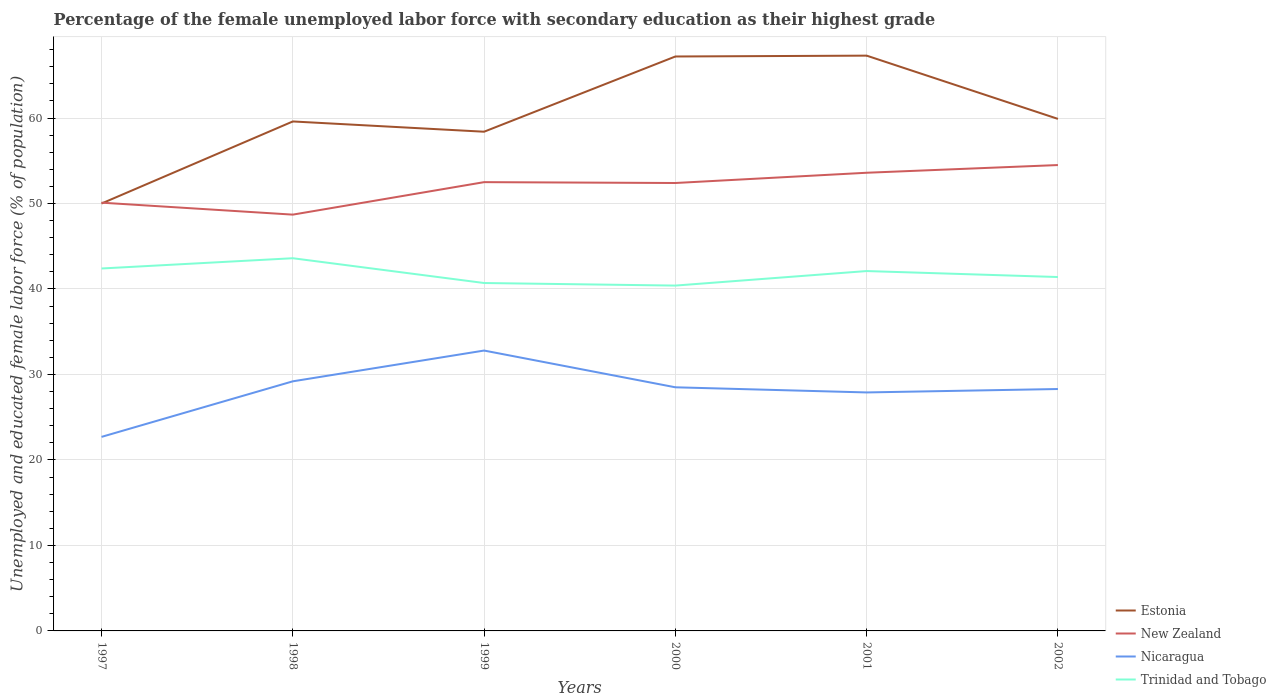Does the line corresponding to Nicaragua intersect with the line corresponding to Trinidad and Tobago?
Your answer should be compact. No. Across all years, what is the maximum percentage of the unemployed female labor force with secondary education in Estonia?
Offer a very short reply. 50. In which year was the percentage of the unemployed female labor force with secondary education in Estonia maximum?
Offer a terse response. 1997. What is the total percentage of the unemployed female labor force with secondary education in Estonia in the graph?
Give a very brief answer. -8.8. What is the difference between the highest and the second highest percentage of the unemployed female labor force with secondary education in Trinidad and Tobago?
Provide a succinct answer. 3.2. How many years are there in the graph?
Offer a terse response. 6. Where does the legend appear in the graph?
Provide a short and direct response. Bottom right. What is the title of the graph?
Keep it short and to the point. Percentage of the female unemployed labor force with secondary education as their highest grade. What is the label or title of the X-axis?
Give a very brief answer. Years. What is the label or title of the Y-axis?
Offer a terse response. Unemployed and educated female labor force (% of population). What is the Unemployed and educated female labor force (% of population) in Estonia in 1997?
Make the answer very short. 50. What is the Unemployed and educated female labor force (% of population) in New Zealand in 1997?
Your answer should be very brief. 50.1. What is the Unemployed and educated female labor force (% of population) of Nicaragua in 1997?
Provide a succinct answer. 22.7. What is the Unemployed and educated female labor force (% of population) of Trinidad and Tobago in 1997?
Provide a succinct answer. 42.4. What is the Unemployed and educated female labor force (% of population) of Estonia in 1998?
Provide a short and direct response. 59.6. What is the Unemployed and educated female labor force (% of population) of New Zealand in 1998?
Offer a terse response. 48.7. What is the Unemployed and educated female labor force (% of population) of Nicaragua in 1998?
Offer a terse response. 29.2. What is the Unemployed and educated female labor force (% of population) in Trinidad and Tobago in 1998?
Your answer should be compact. 43.6. What is the Unemployed and educated female labor force (% of population) in Estonia in 1999?
Your response must be concise. 58.4. What is the Unemployed and educated female labor force (% of population) of New Zealand in 1999?
Provide a succinct answer. 52.5. What is the Unemployed and educated female labor force (% of population) in Nicaragua in 1999?
Keep it short and to the point. 32.8. What is the Unemployed and educated female labor force (% of population) in Trinidad and Tobago in 1999?
Offer a terse response. 40.7. What is the Unemployed and educated female labor force (% of population) in Estonia in 2000?
Make the answer very short. 67.2. What is the Unemployed and educated female labor force (% of population) in New Zealand in 2000?
Provide a succinct answer. 52.4. What is the Unemployed and educated female labor force (% of population) in Nicaragua in 2000?
Provide a short and direct response. 28.5. What is the Unemployed and educated female labor force (% of population) of Trinidad and Tobago in 2000?
Ensure brevity in your answer.  40.4. What is the Unemployed and educated female labor force (% of population) in Estonia in 2001?
Your response must be concise. 67.3. What is the Unemployed and educated female labor force (% of population) of New Zealand in 2001?
Keep it short and to the point. 53.6. What is the Unemployed and educated female labor force (% of population) in Nicaragua in 2001?
Offer a very short reply. 27.9. What is the Unemployed and educated female labor force (% of population) in Trinidad and Tobago in 2001?
Keep it short and to the point. 42.1. What is the Unemployed and educated female labor force (% of population) in Estonia in 2002?
Give a very brief answer. 59.9. What is the Unemployed and educated female labor force (% of population) in New Zealand in 2002?
Make the answer very short. 54.5. What is the Unemployed and educated female labor force (% of population) of Nicaragua in 2002?
Offer a very short reply. 28.3. What is the Unemployed and educated female labor force (% of population) of Trinidad and Tobago in 2002?
Your answer should be very brief. 41.4. Across all years, what is the maximum Unemployed and educated female labor force (% of population) of Estonia?
Your answer should be compact. 67.3. Across all years, what is the maximum Unemployed and educated female labor force (% of population) in New Zealand?
Give a very brief answer. 54.5. Across all years, what is the maximum Unemployed and educated female labor force (% of population) in Nicaragua?
Offer a terse response. 32.8. Across all years, what is the maximum Unemployed and educated female labor force (% of population) of Trinidad and Tobago?
Your answer should be compact. 43.6. Across all years, what is the minimum Unemployed and educated female labor force (% of population) of Estonia?
Your response must be concise. 50. Across all years, what is the minimum Unemployed and educated female labor force (% of population) in New Zealand?
Your response must be concise. 48.7. Across all years, what is the minimum Unemployed and educated female labor force (% of population) in Nicaragua?
Provide a succinct answer. 22.7. Across all years, what is the minimum Unemployed and educated female labor force (% of population) of Trinidad and Tobago?
Keep it short and to the point. 40.4. What is the total Unemployed and educated female labor force (% of population) of Estonia in the graph?
Give a very brief answer. 362.4. What is the total Unemployed and educated female labor force (% of population) of New Zealand in the graph?
Provide a short and direct response. 311.8. What is the total Unemployed and educated female labor force (% of population) in Nicaragua in the graph?
Provide a succinct answer. 169.4. What is the total Unemployed and educated female labor force (% of population) of Trinidad and Tobago in the graph?
Keep it short and to the point. 250.6. What is the difference between the Unemployed and educated female labor force (% of population) of Estonia in 1997 and that in 1998?
Offer a terse response. -9.6. What is the difference between the Unemployed and educated female labor force (% of population) in New Zealand in 1997 and that in 1998?
Give a very brief answer. 1.4. What is the difference between the Unemployed and educated female labor force (% of population) in Trinidad and Tobago in 1997 and that in 1998?
Provide a short and direct response. -1.2. What is the difference between the Unemployed and educated female labor force (% of population) in Estonia in 1997 and that in 1999?
Ensure brevity in your answer.  -8.4. What is the difference between the Unemployed and educated female labor force (% of population) of Estonia in 1997 and that in 2000?
Provide a short and direct response. -17.2. What is the difference between the Unemployed and educated female labor force (% of population) in Estonia in 1997 and that in 2001?
Your answer should be compact. -17.3. What is the difference between the Unemployed and educated female labor force (% of population) of New Zealand in 1997 and that in 2001?
Your response must be concise. -3.5. What is the difference between the Unemployed and educated female labor force (% of population) of Trinidad and Tobago in 1997 and that in 2001?
Offer a terse response. 0.3. What is the difference between the Unemployed and educated female labor force (% of population) in New Zealand in 1997 and that in 2002?
Your response must be concise. -4.4. What is the difference between the Unemployed and educated female labor force (% of population) of Nicaragua in 1997 and that in 2002?
Offer a very short reply. -5.6. What is the difference between the Unemployed and educated female labor force (% of population) in Trinidad and Tobago in 1998 and that in 1999?
Your answer should be very brief. 2.9. What is the difference between the Unemployed and educated female labor force (% of population) in Estonia in 1998 and that in 2000?
Keep it short and to the point. -7.6. What is the difference between the Unemployed and educated female labor force (% of population) in New Zealand in 1998 and that in 2000?
Your response must be concise. -3.7. What is the difference between the Unemployed and educated female labor force (% of population) in Nicaragua in 1998 and that in 2000?
Keep it short and to the point. 0.7. What is the difference between the Unemployed and educated female labor force (% of population) of Estonia in 1998 and that in 2001?
Your response must be concise. -7.7. What is the difference between the Unemployed and educated female labor force (% of population) of Trinidad and Tobago in 1998 and that in 2001?
Your answer should be compact. 1.5. What is the difference between the Unemployed and educated female labor force (% of population) in Estonia in 1998 and that in 2002?
Keep it short and to the point. -0.3. What is the difference between the Unemployed and educated female labor force (% of population) in Nicaragua in 1998 and that in 2002?
Provide a short and direct response. 0.9. What is the difference between the Unemployed and educated female labor force (% of population) of New Zealand in 1999 and that in 2000?
Provide a short and direct response. 0.1. What is the difference between the Unemployed and educated female labor force (% of population) of Nicaragua in 1999 and that in 2000?
Your response must be concise. 4.3. What is the difference between the Unemployed and educated female labor force (% of population) of Trinidad and Tobago in 1999 and that in 2000?
Keep it short and to the point. 0.3. What is the difference between the Unemployed and educated female labor force (% of population) of New Zealand in 1999 and that in 2001?
Offer a very short reply. -1.1. What is the difference between the Unemployed and educated female labor force (% of population) in Nicaragua in 1999 and that in 2001?
Your response must be concise. 4.9. What is the difference between the Unemployed and educated female labor force (% of population) in Estonia in 1999 and that in 2002?
Your answer should be compact. -1.5. What is the difference between the Unemployed and educated female labor force (% of population) in Trinidad and Tobago in 2000 and that in 2001?
Keep it short and to the point. -1.7. What is the difference between the Unemployed and educated female labor force (% of population) in Estonia in 2000 and that in 2002?
Make the answer very short. 7.3. What is the difference between the Unemployed and educated female labor force (% of population) in New Zealand in 2000 and that in 2002?
Make the answer very short. -2.1. What is the difference between the Unemployed and educated female labor force (% of population) in Nicaragua in 2000 and that in 2002?
Your response must be concise. 0.2. What is the difference between the Unemployed and educated female labor force (% of population) of Estonia in 2001 and that in 2002?
Offer a very short reply. 7.4. What is the difference between the Unemployed and educated female labor force (% of population) of Estonia in 1997 and the Unemployed and educated female labor force (% of population) of New Zealand in 1998?
Your answer should be very brief. 1.3. What is the difference between the Unemployed and educated female labor force (% of population) of Estonia in 1997 and the Unemployed and educated female labor force (% of population) of Nicaragua in 1998?
Provide a succinct answer. 20.8. What is the difference between the Unemployed and educated female labor force (% of population) of New Zealand in 1997 and the Unemployed and educated female labor force (% of population) of Nicaragua in 1998?
Keep it short and to the point. 20.9. What is the difference between the Unemployed and educated female labor force (% of population) in Nicaragua in 1997 and the Unemployed and educated female labor force (% of population) in Trinidad and Tobago in 1998?
Keep it short and to the point. -20.9. What is the difference between the Unemployed and educated female labor force (% of population) in Estonia in 1997 and the Unemployed and educated female labor force (% of population) in New Zealand in 1999?
Your answer should be compact. -2.5. What is the difference between the Unemployed and educated female labor force (% of population) of New Zealand in 1997 and the Unemployed and educated female labor force (% of population) of Nicaragua in 1999?
Provide a short and direct response. 17.3. What is the difference between the Unemployed and educated female labor force (% of population) in Nicaragua in 1997 and the Unemployed and educated female labor force (% of population) in Trinidad and Tobago in 1999?
Your answer should be compact. -18. What is the difference between the Unemployed and educated female labor force (% of population) in Estonia in 1997 and the Unemployed and educated female labor force (% of population) in Trinidad and Tobago in 2000?
Your response must be concise. 9.6. What is the difference between the Unemployed and educated female labor force (% of population) in New Zealand in 1997 and the Unemployed and educated female labor force (% of population) in Nicaragua in 2000?
Keep it short and to the point. 21.6. What is the difference between the Unemployed and educated female labor force (% of population) in Nicaragua in 1997 and the Unemployed and educated female labor force (% of population) in Trinidad and Tobago in 2000?
Give a very brief answer. -17.7. What is the difference between the Unemployed and educated female labor force (% of population) of Estonia in 1997 and the Unemployed and educated female labor force (% of population) of Nicaragua in 2001?
Offer a terse response. 22.1. What is the difference between the Unemployed and educated female labor force (% of population) in Estonia in 1997 and the Unemployed and educated female labor force (% of population) in Trinidad and Tobago in 2001?
Offer a terse response. 7.9. What is the difference between the Unemployed and educated female labor force (% of population) of Nicaragua in 1997 and the Unemployed and educated female labor force (% of population) of Trinidad and Tobago in 2001?
Ensure brevity in your answer.  -19.4. What is the difference between the Unemployed and educated female labor force (% of population) in Estonia in 1997 and the Unemployed and educated female labor force (% of population) in New Zealand in 2002?
Provide a short and direct response. -4.5. What is the difference between the Unemployed and educated female labor force (% of population) of Estonia in 1997 and the Unemployed and educated female labor force (% of population) of Nicaragua in 2002?
Ensure brevity in your answer.  21.7. What is the difference between the Unemployed and educated female labor force (% of population) in New Zealand in 1997 and the Unemployed and educated female labor force (% of population) in Nicaragua in 2002?
Make the answer very short. 21.8. What is the difference between the Unemployed and educated female labor force (% of population) in Nicaragua in 1997 and the Unemployed and educated female labor force (% of population) in Trinidad and Tobago in 2002?
Provide a succinct answer. -18.7. What is the difference between the Unemployed and educated female labor force (% of population) of Estonia in 1998 and the Unemployed and educated female labor force (% of population) of New Zealand in 1999?
Your answer should be compact. 7.1. What is the difference between the Unemployed and educated female labor force (% of population) of Estonia in 1998 and the Unemployed and educated female labor force (% of population) of Nicaragua in 1999?
Your answer should be compact. 26.8. What is the difference between the Unemployed and educated female labor force (% of population) of Estonia in 1998 and the Unemployed and educated female labor force (% of population) of Trinidad and Tobago in 1999?
Your answer should be compact. 18.9. What is the difference between the Unemployed and educated female labor force (% of population) of New Zealand in 1998 and the Unemployed and educated female labor force (% of population) of Nicaragua in 1999?
Your answer should be compact. 15.9. What is the difference between the Unemployed and educated female labor force (% of population) of Estonia in 1998 and the Unemployed and educated female labor force (% of population) of New Zealand in 2000?
Make the answer very short. 7.2. What is the difference between the Unemployed and educated female labor force (% of population) of Estonia in 1998 and the Unemployed and educated female labor force (% of population) of Nicaragua in 2000?
Your answer should be very brief. 31.1. What is the difference between the Unemployed and educated female labor force (% of population) in New Zealand in 1998 and the Unemployed and educated female labor force (% of population) in Nicaragua in 2000?
Make the answer very short. 20.2. What is the difference between the Unemployed and educated female labor force (% of population) of New Zealand in 1998 and the Unemployed and educated female labor force (% of population) of Trinidad and Tobago in 2000?
Keep it short and to the point. 8.3. What is the difference between the Unemployed and educated female labor force (% of population) of Nicaragua in 1998 and the Unemployed and educated female labor force (% of population) of Trinidad and Tobago in 2000?
Offer a very short reply. -11.2. What is the difference between the Unemployed and educated female labor force (% of population) in Estonia in 1998 and the Unemployed and educated female labor force (% of population) in New Zealand in 2001?
Give a very brief answer. 6. What is the difference between the Unemployed and educated female labor force (% of population) of Estonia in 1998 and the Unemployed and educated female labor force (% of population) of Nicaragua in 2001?
Your answer should be very brief. 31.7. What is the difference between the Unemployed and educated female labor force (% of population) in New Zealand in 1998 and the Unemployed and educated female labor force (% of population) in Nicaragua in 2001?
Provide a succinct answer. 20.8. What is the difference between the Unemployed and educated female labor force (% of population) in New Zealand in 1998 and the Unemployed and educated female labor force (% of population) in Trinidad and Tobago in 2001?
Provide a succinct answer. 6.6. What is the difference between the Unemployed and educated female labor force (% of population) of Nicaragua in 1998 and the Unemployed and educated female labor force (% of population) of Trinidad and Tobago in 2001?
Your answer should be compact. -12.9. What is the difference between the Unemployed and educated female labor force (% of population) of Estonia in 1998 and the Unemployed and educated female labor force (% of population) of New Zealand in 2002?
Offer a very short reply. 5.1. What is the difference between the Unemployed and educated female labor force (% of population) of Estonia in 1998 and the Unemployed and educated female labor force (% of population) of Nicaragua in 2002?
Provide a short and direct response. 31.3. What is the difference between the Unemployed and educated female labor force (% of population) of New Zealand in 1998 and the Unemployed and educated female labor force (% of population) of Nicaragua in 2002?
Offer a very short reply. 20.4. What is the difference between the Unemployed and educated female labor force (% of population) in New Zealand in 1998 and the Unemployed and educated female labor force (% of population) in Trinidad and Tobago in 2002?
Provide a short and direct response. 7.3. What is the difference between the Unemployed and educated female labor force (% of population) of Estonia in 1999 and the Unemployed and educated female labor force (% of population) of Nicaragua in 2000?
Your response must be concise. 29.9. What is the difference between the Unemployed and educated female labor force (% of population) in Estonia in 1999 and the Unemployed and educated female labor force (% of population) in Trinidad and Tobago in 2000?
Ensure brevity in your answer.  18. What is the difference between the Unemployed and educated female labor force (% of population) in Estonia in 1999 and the Unemployed and educated female labor force (% of population) in Nicaragua in 2001?
Offer a terse response. 30.5. What is the difference between the Unemployed and educated female labor force (% of population) in Estonia in 1999 and the Unemployed and educated female labor force (% of population) in Trinidad and Tobago in 2001?
Your answer should be very brief. 16.3. What is the difference between the Unemployed and educated female labor force (% of population) in New Zealand in 1999 and the Unemployed and educated female labor force (% of population) in Nicaragua in 2001?
Your answer should be very brief. 24.6. What is the difference between the Unemployed and educated female labor force (% of population) in Nicaragua in 1999 and the Unemployed and educated female labor force (% of population) in Trinidad and Tobago in 2001?
Ensure brevity in your answer.  -9.3. What is the difference between the Unemployed and educated female labor force (% of population) in Estonia in 1999 and the Unemployed and educated female labor force (% of population) in New Zealand in 2002?
Offer a very short reply. 3.9. What is the difference between the Unemployed and educated female labor force (% of population) of Estonia in 1999 and the Unemployed and educated female labor force (% of population) of Nicaragua in 2002?
Provide a succinct answer. 30.1. What is the difference between the Unemployed and educated female labor force (% of population) of New Zealand in 1999 and the Unemployed and educated female labor force (% of population) of Nicaragua in 2002?
Provide a short and direct response. 24.2. What is the difference between the Unemployed and educated female labor force (% of population) in New Zealand in 1999 and the Unemployed and educated female labor force (% of population) in Trinidad and Tobago in 2002?
Provide a succinct answer. 11.1. What is the difference between the Unemployed and educated female labor force (% of population) of Nicaragua in 1999 and the Unemployed and educated female labor force (% of population) of Trinidad and Tobago in 2002?
Make the answer very short. -8.6. What is the difference between the Unemployed and educated female labor force (% of population) in Estonia in 2000 and the Unemployed and educated female labor force (% of population) in New Zealand in 2001?
Keep it short and to the point. 13.6. What is the difference between the Unemployed and educated female labor force (% of population) in Estonia in 2000 and the Unemployed and educated female labor force (% of population) in Nicaragua in 2001?
Ensure brevity in your answer.  39.3. What is the difference between the Unemployed and educated female labor force (% of population) of Estonia in 2000 and the Unemployed and educated female labor force (% of population) of Trinidad and Tobago in 2001?
Provide a succinct answer. 25.1. What is the difference between the Unemployed and educated female labor force (% of population) of New Zealand in 2000 and the Unemployed and educated female labor force (% of population) of Trinidad and Tobago in 2001?
Your response must be concise. 10.3. What is the difference between the Unemployed and educated female labor force (% of population) in Nicaragua in 2000 and the Unemployed and educated female labor force (% of population) in Trinidad and Tobago in 2001?
Give a very brief answer. -13.6. What is the difference between the Unemployed and educated female labor force (% of population) in Estonia in 2000 and the Unemployed and educated female labor force (% of population) in New Zealand in 2002?
Your answer should be very brief. 12.7. What is the difference between the Unemployed and educated female labor force (% of population) of Estonia in 2000 and the Unemployed and educated female labor force (% of population) of Nicaragua in 2002?
Your answer should be very brief. 38.9. What is the difference between the Unemployed and educated female labor force (% of population) in Estonia in 2000 and the Unemployed and educated female labor force (% of population) in Trinidad and Tobago in 2002?
Offer a very short reply. 25.8. What is the difference between the Unemployed and educated female labor force (% of population) in New Zealand in 2000 and the Unemployed and educated female labor force (% of population) in Nicaragua in 2002?
Your response must be concise. 24.1. What is the difference between the Unemployed and educated female labor force (% of population) in Nicaragua in 2000 and the Unemployed and educated female labor force (% of population) in Trinidad and Tobago in 2002?
Make the answer very short. -12.9. What is the difference between the Unemployed and educated female labor force (% of population) in Estonia in 2001 and the Unemployed and educated female labor force (% of population) in New Zealand in 2002?
Offer a terse response. 12.8. What is the difference between the Unemployed and educated female labor force (% of population) in Estonia in 2001 and the Unemployed and educated female labor force (% of population) in Nicaragua in 2002?
Offer a very short reply. 39. What is the difference between the Unemployed and educated female labor force (% of population) of Estonia in 2001 and the Unemployed and educated female labor force (% of population) of Trinidad and Tobago in 2002?
Offer a very short reply. 25.9. What is the difference between the Unemployed and educated female labor force (% of population) of New Zealand in 2001 and the Unemployed and educated female labor force (% of population) of Nicaragua in 2002?
Your response must be concise. 25.3. What is the average Unemployed and educated female labor force (% of population) in Estonia per year?
Keep it short and to the point. 60.4. What is the average Unemployed and educated female labor force (% of population) in New Zealand per year?
Give a very brief answer. 51.97. What is the average Unemployed and educated female labor force (% of population) in Nicaragua per year?
Provide a short and direct response. 28.23. What is the average Unemployed and educated female labor force (% of population) of Trinidad and Tobago per year?
Your answer should be very brief. 41.77. In the year 1997, what is the difference between the Unemployed and educated female labor force (% of population) of Estonia and Unemployed and educated female labor force (% of population) of New Zealand?
Provide a short and direct response. -0.1. In the year 1997, what is the difference between the Unemployed and educated female labor force (% of population) in Estonia and Unemployed and educated female labor force (% of population) in Nicaragua?
Provide a succinct answer. 27.3. In the year 1997, what is the difference between the Unemployed and educated female labor force (% of population) in New Zealand and Unemployed and educated female labor force (% of population) in Nicaragua?
Your answer should be compact. 27.4. In the year 1997, what is the difference between the Unemployed and educated female labor force (% of population) of New Zealand and Unemployed and educated female labor force (% of population) of Trinidad and Tobago?
Give a very brief answer. 7.7. In the year 1997, what is the difference between the Unemployed and educated female labor force (% of population) of Nicaragua and Unemployed and educated female labor force (% of population) of Trinidad and Tobago?
Provide a short and direct response. -19.7. In the year 1998, what is the difference between the Unemployed and educated female labor force (% of population) in Estonia and Unemployed and educated female labor force (% of population) in Nicaragua?
Make the answer very short. 30.4. In the year 1998, what is the difference between the Unemployed and educated female labor force (% of population) in New Zealand and Unemployed and educated female labor force (% of population) in Nicaragua?
Give a very brief answer. 19.5. In the year 1998, what is the difference between the Unemployed and educated female labor force (% of population) in Nicaragua and Unemployed and educated female labor force (% of population) in Trinidad and Tobago?
Offer a terse response. -14.4. In the year 1999, what is the difference between the Unemployed and educated female labor force (% of population) of Estonia and Unemployed and educated female labor force (% of population) of Nicaragua?
Your answer should be very brief. 25.6. In the year 1999, what is the difference between the Unemployed and educated female labor force (% of population) in Estonia and Unemployed and educated female labor force (% of population) in Trinidad and Tobago?
Ensure brevity in your answer.  17.7. In the year 1999, what is the difference between the Unemployed and educated female labor force (% of population) of New Zealand and Unemployed and educated female labor force (% of population) of Nicaragua?
Offer a very short reply. 19.7. In the year 1999, what is the difference between the Unemployed and educated female labor force (% of population) in New Zealand and Unemployed and educated female labor force (% of population) in Trinidad and Tobago?
Provide a succinct answer. 11.8. In the year 1999, what is the difference between the Unemployed and educated female labor force (% of population) in Nicaragua and Unemployed and educated female labor force (% of population) in Trinidad and Tobago?
Your answer should be compact. -7.9. In the year 2000, what is the difference between the Unemployed and educated female labor force (% of population) in Estonia and Unemployed and educated female labor force (% of population) in New Zealand?
Provide a succinct answer. 14.8. In the year 2000, what is the difference between the Unemployed and educated female labor force (% of population) of Estonia and Unemployed and educated female labor force (% of population) of Nicaragua?
Provide a short and direct response. 38.7. In the year 2000, what is the difference between the Unemployed and educated female labor force (% of population) of Estonia and Unemployed and educated female labor force (% of population) of Trinidad and Tobago?
Your answer should be very brief. 26.8. In the year 2000, what is the difference between the Unemployed and educated female labor force (% of population) in New Zealand and Unemployed and educated female labor force (% of population) in Nicaragua?
Your answer should be very brief. 23.9. In the year 2000, what is the difference between the Unemployed and educated female labor force (% of population) in New Zealand and Unemployed and educated female labor force (% of population) in Trinidad and Tobago?
Offer a terse response. 12. In the year 2000, what is the difference between the Unemployed and educated female labor force (% of population) in Nicaragua and Unemployed and educated female labor force (% of population) in Trinidad and Tobago?
Make the answer very short. -11.9. In the year 2001, what is the difference between the Unemployed and educated female labor force (% of population) in Estonia and Unemployed and educated female labor force (% of population) in Nicaragua?
Ensure brevity in your answer.  39.4. In the year 2001, what is the difference between the Unemployed and educated female labor force (% of population) of Estonia and Unemployed and educated female labor force (% of population) of Trinidad and Tobago?
Your answer should be compact. 25.2. In the year 2001, what is the difference between the Unemployed and educated female labor force (% of population) in New Zealand and Unemployed and educated female labor force (% of population) in Nicaragua?
Ensure brevity in your answer.  25.7. In the year 2001, what is the difference between the Unemployed and educated female labor force (% of population) in New Zealand and Unemployed and educated female labor force (% of population) in Trinidad and Tobago?
Offer a very short reply. 11.5. In the year 2002, what is the difference between the Unemployed and educated female labor force (% of population) of Estonia and Unemployed and educated female labor force (% of population) of Nicaragua?
Keep it short and to the point. 31.6. In the year 2002, what is the difference between the Unemployed and educated female labor force (% of population) of New Zealand and Unemployed and educated female labor force (% of population) of Nicaragua?
Offer a terse response. 26.2. What is the ratio of the Unemployed and educated female labor force (% of population) of Estonia in 1997 to that in 1998?
Provide a short and direct response. 0.84. What is the ratio of the Unemployed and educated female labor force (% of population) in New Zealand in 1997 to that in 1998?
Provide a succinct answer. 1.03. What is the ratio of the Unemployed and educated female labor force (% of population) of Nicaragua in 1997 to that in 1998?
Provide a succinct answer. 0.78. What is the ratio of the Unemployed and educated female labor force (% of population) of Trinidad and Tobago in 1997 to that in 1998?
Provide a short and direct response. 0.97. What is the ratio of the Unemployed and educated female labor force (% of population) in Estonia in 1997 to that in 1999?
Keep it short and to the point. 0.86. What is the ratio of the Unemployed and educated female labor force (% of population) of New Zealand in 1997 to that in 1999?
Keep it short and to the point. 0.95. What is the ratio of the Unemployed and educated female labor force (% of population) in Nicaragua in 1997 to that in 1999?
Ensure brevity in your answer.  0.69. What is the ratio of the Unemployed and educated female labor force (% of population) in Trinidad and Tobago in 1997 to that in 1999?
Your answer should be compact. 1.04. What is the ratio of the Unemployed and educated female labor force (% of population) of Estonia in 1997 to that in 2000?
Your answer should be compact. 0.74. What is the ratio of the Unemployed and educated female labor force (% of population) of New Zealand in 1997 to that in 2000?
Ensure brevity in your answer.  0.96. What is the ratio of the Unemployed and educated female labor force (% of population) of Nicaragua in 1997 to that in 2000?
Your answer should be very brief. 0.8. What is the ratio of the Unemployed and educated female labor force (% of population) in Trinidad and Tobago in 1997 to that in 2000?
Ensure brevity in your answer.  1.05. What is the ratio of the Unemployed and educated female labor force (% of population) in Estonia in 1997 to that in 2001?
Offer a terse response. 0.74. What is the ratio of the Unemployed and educated female labor force (% of population) of New Zealand in 1997 to that in 2001?
Provide a short and direct response. 0.93. What is the ratio of the Unemployed and educated female labor force (% of population) in Nicaragua in 1997 to that in 2001?
Offer a very short reply. 0.81. What is the ratio of the Unemployed and educated female labor force (% of population) in Trinidad and Tobago in 1997 to that in 2001?
Keep it short and to the point. 1.01. What is the ratio of the Unemployed and educated female labor force (% of population) of Estonia in 1997 to that in 2002?
Ensure brevity in your answer.  0.83. What is the ratio of the Unemployed and educated female labor force (% of population) in New Zealand in 1997 to that in 2002?
Your response must be concise. 0.92. What is the ratio of the Unemployed and educated female labor force (% of population) in Nicaragua in 1997 to that in 2002?
Make the answer very short. 0.8. What is the ratio of the Unemployed and educated female labor force (% of population) of Trinidad and Tobago in 1997 to that in 2002?
Your response must be concise. 1.02. What is the ratio of the Unemployed and educated female labor force (% of population) in Estonia in 1998 to that in 1999?
Provide a short and direct response. 1.02. What is the ratio of the Unemployed and educated female labor force (% of population) of New Zealand in 1998 to that in 1999?
Offer a terse response. 0.93. What is the ratio of the Unemployed and educated female labor force (% of population) in Nicaragua in 1998 to that in 1999?
Give a very brief answer. 0.89. What is the ratio of the Unemployed and educated female labor force (% of population) in Trinidad and Tobago in 1998 to that in 1999?
Offer a terse response. 1.07. What is the ratio of the Unemployed and educated female labor force (% of population) in Estonia in 1998 to that in 2000?
Your answer should be compact. 0.89. What is the ratio of the Unemployed and educated female labor force (% of population) of New Zealand in 1998 to that in 2000?
Your response must be concise. 0.93. What is the ratio of the Unemployed and educated female labor force (% of population) of Nicaragua in 1998 to that in 2000?
Offer a very short reply. 1.02. What is the ratio of the Unemployed and educated female labor force (% of population) of Trinidad and Tobago in 1998 to that in 2000?
Ensure brevity in your answer.  1.08. What is the ratio of the Unemployed and educated female labor force (% of population) in Estonia in 1998 to that in 2001?
Provide a succinct answer. 0.89. What is the ratio of the Unemployed and educated female labor force (% of population) of New Zealand in 1998 to that in 2001?
Your response must be concise. 0.91. What is the ratio of the Unemployed and educated female labor force (% of population) of Nicaragua in 1998 to that in 2001?
Keep it short and to the point. 1.05. What is the ratio of the Unemployed and educated female labor force (% of population) of Trinidad and Tobago in 1998 to that in 2001?
Offer a very short reply. 1.04. What is the ratio of the Unemployed and educated female labor force (% of population) in New Zealand in 1998 to that in 2002?
Your answer should be compact. 0.89. What is the ratio of the Unemployed and educated female labor force (% of population) in Nicaragua in 1998 to that in 2002?
Ensure brevity in your answer.  1.03. What is the ratio of the Unemployed and educated female labor force (% of population) in Trinidad and Tobago in 1998 to that in 2002?
Offer a terse response. 1.05. What is the ratio of the Unemployed and educated female labor force (% of population) of Estonia in 1999 to that in 2000?
Provide a short and direct response. 0.87. What is the ratio of the Unemployed and educated female labor force (% of population) of Nicaragua in 1999 to that in 2000?
Offer a terse response. 1.15. What is the ratio of the Unemployed and educated female labor force (% of population) of Trinidad and Tobago in 1999 to that in 2000?
Keep it short and to the point. 1.01. What is the ratio of the Unemployed and educated female labor force (% of population) of Estonia in 1999 to that in 2001?
Make the answer very short. 0.87. What is the ratio of the Unemployed and educated female labor force (% of population) in New Zealand in 1999 to that in 2001?
Your answer should be very brief. 0.98. What is the ratio of the Unemployed and educated female labor force (% of population) of Nicaragua in 1999 to that in 2001?
Give a very brief answer. 1.18. What is the ratio of the Unemployed and educated female labor force (% of population) in Trinidad and Tobago in 1999 to that in 2001?
Offer a terse response. 0.97. What is the ratio of the Unemployed and educated female labor force (% of population) of New Zealand in 1999 to that in 2002?
Offer a very short reply. 0.96. What is the ratio of the Unemployed and educated female labor force (% of population) in Nicaragua in 1999 to that in 2002?
Offer a very short reply. 1.16. What is the ratio of the Unemployed and educated female labor force (% of population) of Trinidad and Tobago in 1999 to that in 2002?
Keep it short and to the point. 0.98. What is the ratio of the Unemployed and educated female labor force (% of population) in Estonia in 2000 to that in 2001?
Your answer should be very brief. 1. What is the ratio of the Unemployed and educated female labor force (% of population) in New Zealand in 2000 to that in 2001?
Your answer should be very brief. 0.98. What is the ratio of the Unemployed and educated female labor force (% of population) in Nicaragua in 2000 to that in 2001?
Make the answer very short. 1.02. What is the ratio of the Unemployed and educated female labor force (% of population) in Trinidad and Tobago in 2000 to that in 2001?
Keep it short and to the point. 0.96. What is the ratio of the Unemployed and educated female labor force (% of population) of Estonia in 2000 to that in 2002?
Your response must be concise. 1.12. What is the ratio of the Unemployed and educated female labor force (% of population) of New Zealand in 2000 to that in 2002?
Provide a short and direct response. 0.96. What is the ratio of the Unemployed and educated female labor force (% of population) in Nicaragua in 2000 to that in 2002?
Your answer should be very brief. 1.01. What is the ratio of the Unemployed and educated female labor force (% of population) in Trinidad and Tobago in 2000 to that in 2002?
Offer a terse response. 0.98. What is the ratio of the Unemployed and educated female labor force (% of population) in Estonia in 2001 to that in 2002?
Your answer should be very brief. 1.12. What is the ratio of the Unemployed and educated female labor force (% of population) in New Zealand in 2001 to that in 2002?
Give a very brief answer. 0.98. What is the ratio of the Unemployed and educated female labor force (% of population) of Nicaragua in 2001 to that in 2002?
Offer a very short reply. 0.99. What is the ratio of the Unemployed and educated female labor force (% of population) in Trinidad and Tobago in 2001 to that in 2002?
Offer a terse response. 1.02. What is the difference between the highest and the second highest Unemployed and educated female labor force (% of population) in New Zealand?
Your answer should be compact. 0.9. What is the difference between the highest and the second highest Unemployed and educated female labor force (% of population) of Trinidad and Tobago?
Give a very brief answer. 1.2. What is the difference between the highest and the lowest Unemployed and educated female labor force (% of population) in Nicaragua?
Provide a succinct answer. 10.1. 